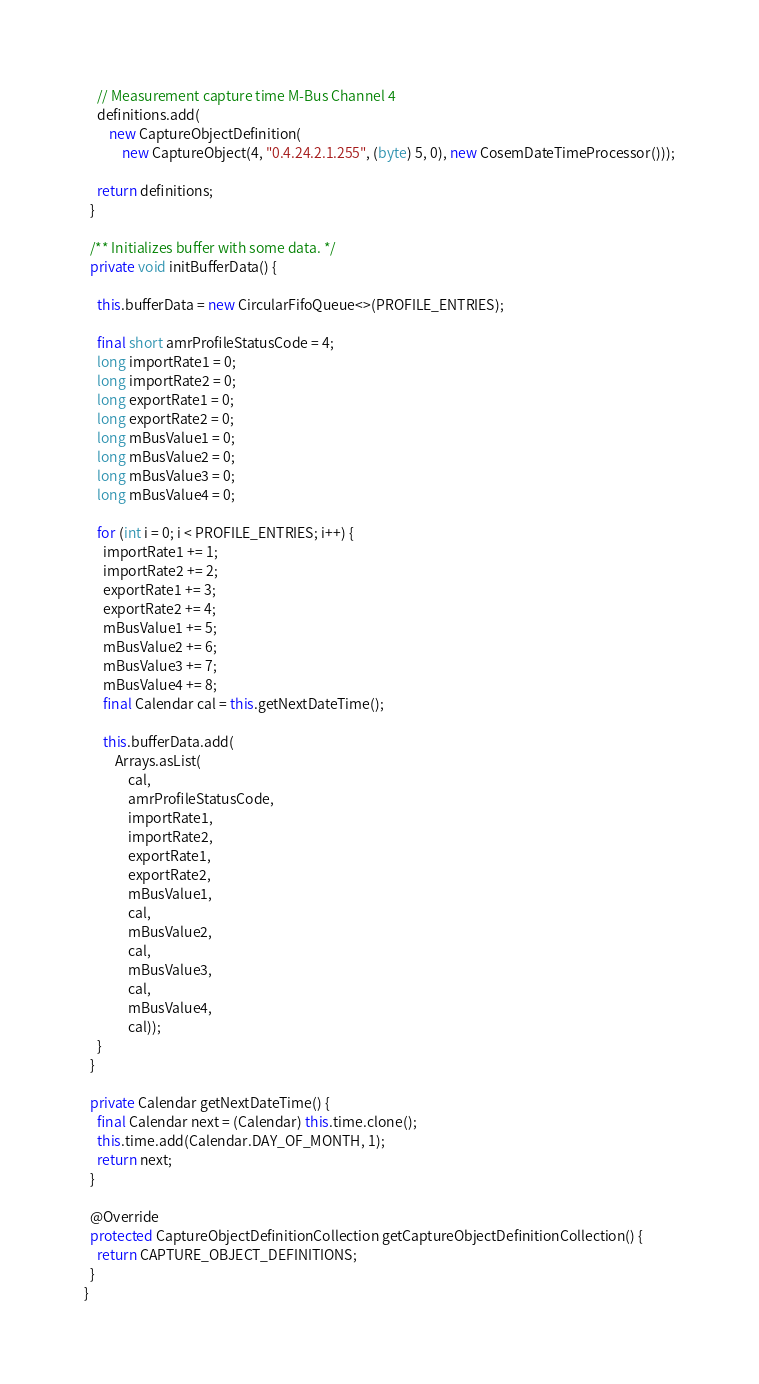<code> <loc_0><loc_0><loc_500><loc_500><_Java_>    // Measurement capture time M-Bus Channel 4
    definitions.add(
        new CaptureObjectDefinition(
            new CaptureObject(4, "0.4.24.2.1.255", (byte) 5, 0), new CosemDateTimeProcessor()));

    return definitions;
  }

  /** Initializes buffer with some data. */
  private void initBufferData() {

    this.bufferData = new CircularFifoQueue<>(PROFILE_ENTRIES);

    final short amrProfileStatusCode = 4;
    long importRate1 = 0;
    long importRate2 = 0;
    long exportRate1 = 0;
    long exportRate2 = 0;
    long mBusValue1 = 0;
    long mBusValue2 = 0;
    long mBusValue3 = 0;
    long mBusValue4 = 0;

    for (int i = 0; i < PROFILE_ENTRIES; i++) {
      importRate1 += 1;
      importRate2 += 2;
      exportRate1 += 3;
      exportRate2 += 4;
      mBusValue1 += 5;
      mBusValue2 += 6;
      mBusValue3 += 7;
      mBusValue4 += 8;
      final Calendar cal = this.getNextDateTime();

      this.bufferData.add(
          Arrays.asList(
              cal,
              amrProfileStatusCode,
              importRate1,
              importRate2,
              exportRate1,
              exportRate2,
              mBusValue1,
              cal,
              mBusValue2,
              cal,
              mBusValue3,
              cal,
              mBusValue4,
              cal));
    }
  }

  private Calendar getNextDateTime() {
    final Calendar next = (Calendar) this.time.clone();
    this.time.add(Calendar.DAY_OF_MONTH, 1);
    return next;
  }

  @Override
  protected CaptureObjectDefinitionCollection getCaptureObjectDefinitionCollection() {
    return CAPTURE_OBJECT_DEFINITIONS;
  }
}
</code> 